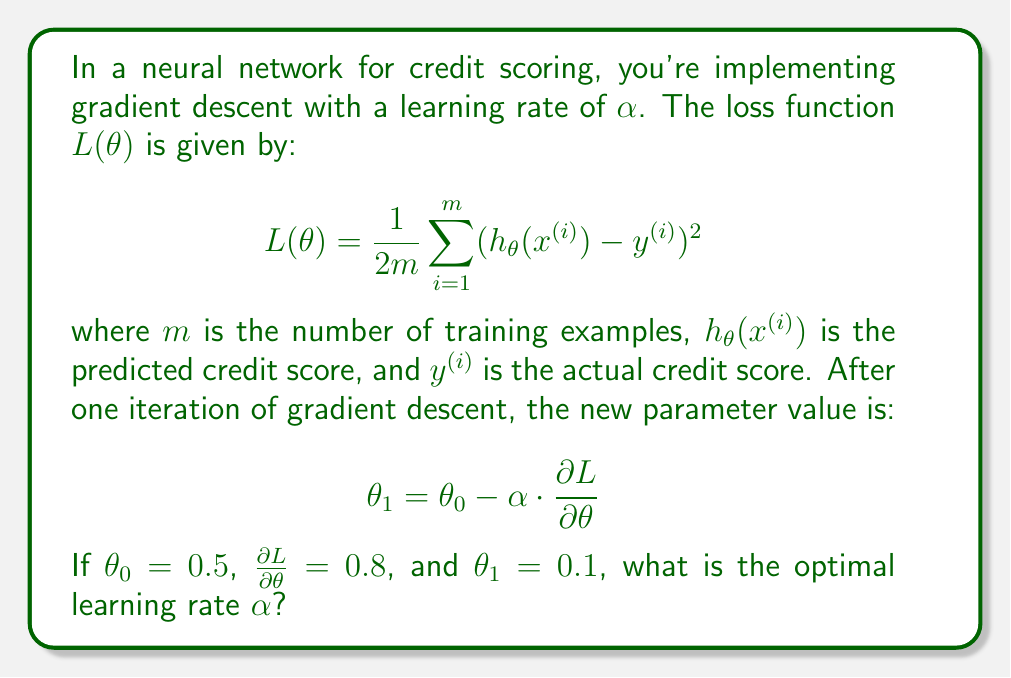Give your solution to this math problem. To solve this problem, we need to use the gradient descent update rule and work backwards to find the learning rate $\alpha$. Let's break it down step-by-step:

1. We're given the gradient descent update rule:
   $$\theta_1 = \theta_0 - \alpha \cdot \frac{\partial L}{\partial \theta}$$

2. We know the following values:
   - $\theta_0 = 0.5$ (initial parameter value)
   - $\frac{\partial L}{\partial \theta} = 0.8$ (gradient)
   - $\theta_1 = 0.1$ (new parameter value after one iteration)

3. Let's substitute these values into the update rule:
   $$0.1 = 0.5 - \alpha \cdot 0.8$$

4. Now, we can solve for $\alpha$:
   $$0.1 - 0.5 = -\alpha \cdot 0.8$$
   $$-0.4 = -0.8\alpha$$

5. Divide both sides by -0.8:
   $$\frac{-0.4}{-0.8} = \alpha$$
   $$0.5 = \alpha$$

Therefore, the optimal learning rate $\alpha$ is 0.5.

This learning rate ensures that the parameter update moves from 0.5 to 0.1 in one iteration of gradient descent, given the current gradient of 0.8.
Answer: $\alpha = 0.5$ 